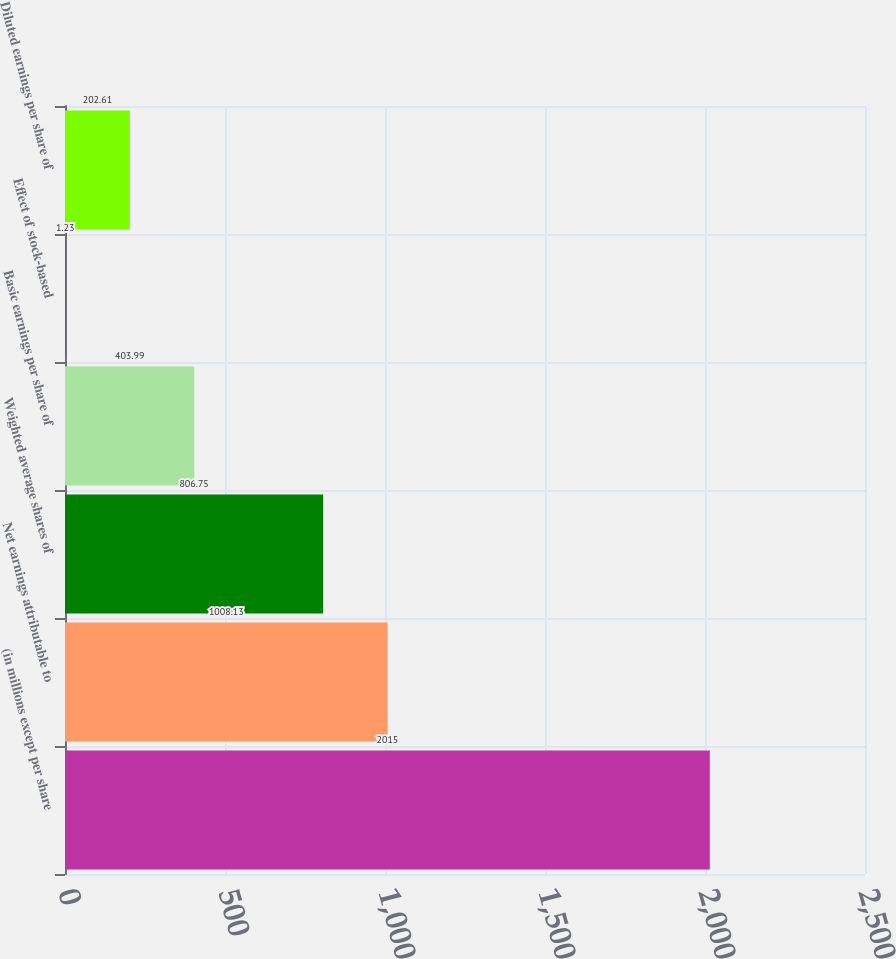Convert chart to OTSL. <chart><loc_0><loc_0><loc_500><loc_500><bar_chart><fcel>(in millions except per share<fcel>Net earnings attributable to<fcel>Weighted average shares of<fcel>Basic earnings per share of<fcel>Effect of stock-based<fcel>Diluted earnings per share of<nl><fcel>2015<fcel>1008.13<fcel>806.75<fcel>403.99<fcel>1.23<fcel>202.61<nl></chart> 